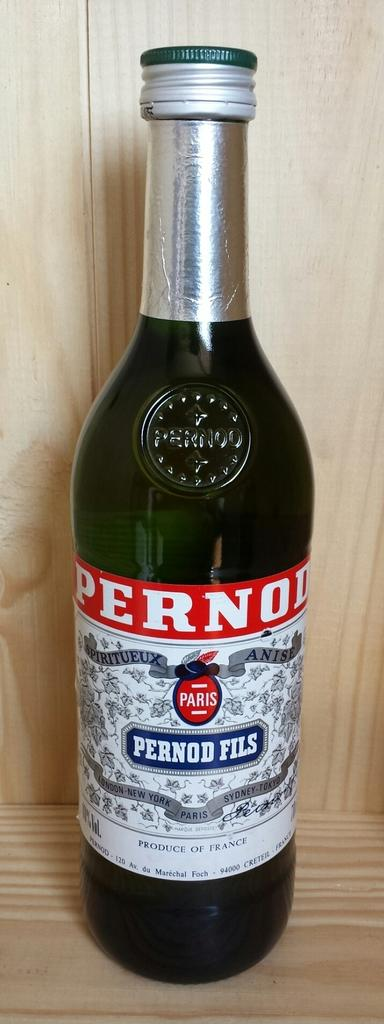<image>
Render a clear and concise summary of the photo. bottle of pernod fils made in france on a wooden shelf 